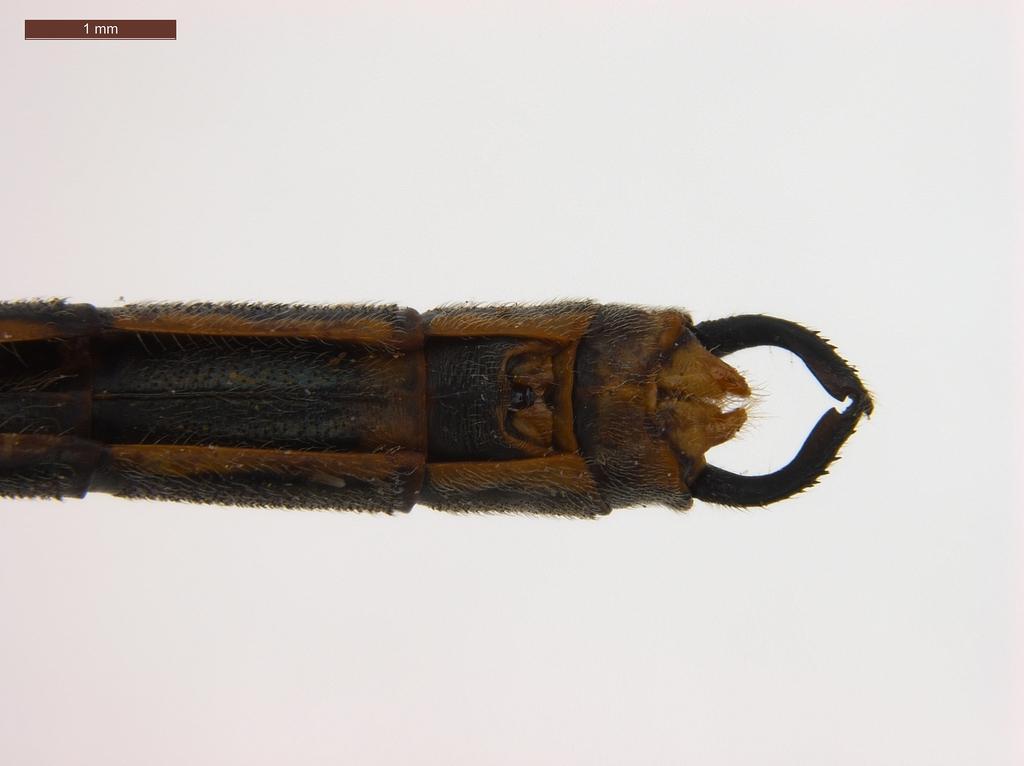How would you summarize this image in a sentence or two? In the center of the image there is some object. There is a text on the top left of the image. 